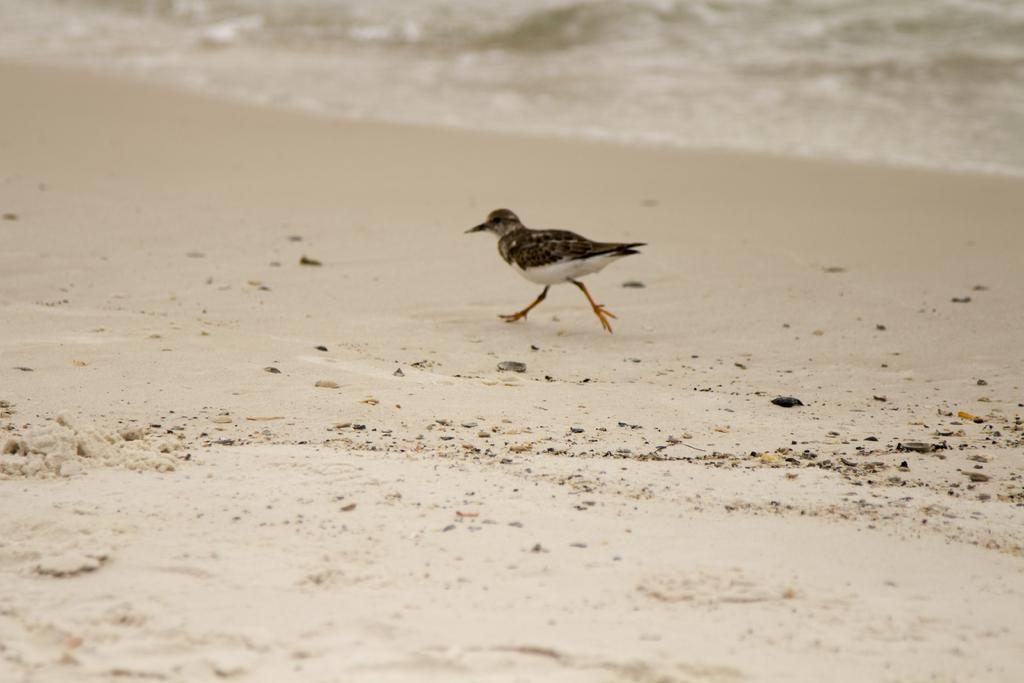What type of animal is in the image? There is a bird in the image. What is the bird doing in the image? The bird is walking on sand. What else can be seen in the image besides the bird? There is water visible in the image. What type of mitten is the bird wearing on its feet in the image? There is no mitten present in the image; the bird is walking on sand with its natural feet. 